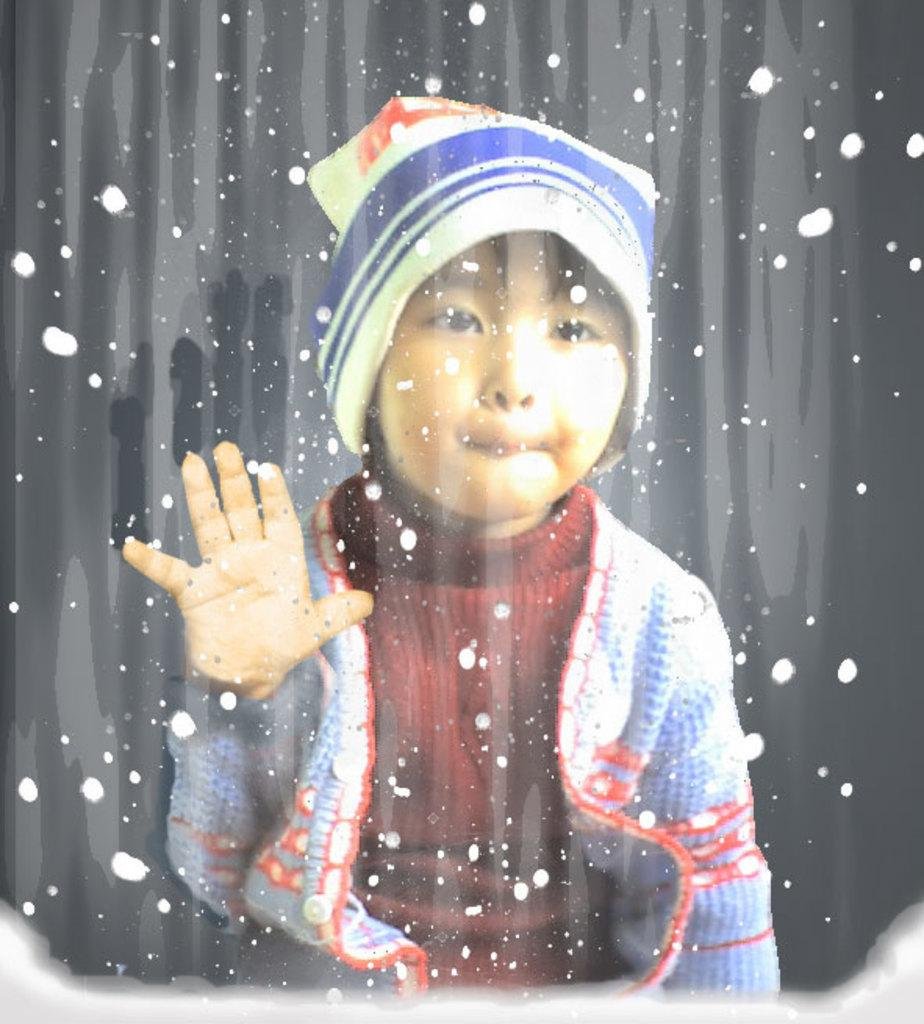What is the main subject of the image? The main subject of the image is a child. What is the child wearing on their upper body? The child is wearing a red t-shirt. What type of headwear is the child wearing? The child is wearing a cap. What material is the child touching in the image? The child is touching a glass material. What color or pattern is on the glass material? The glass material has white dots on it. What type of frog can be seen sitting on the child's shoulder in the image? There is no frog present in the image; the child is only touching a glass material with white dots. Who is the child representing in the image? The image does not indicate that the child is representing anyone or anything. 